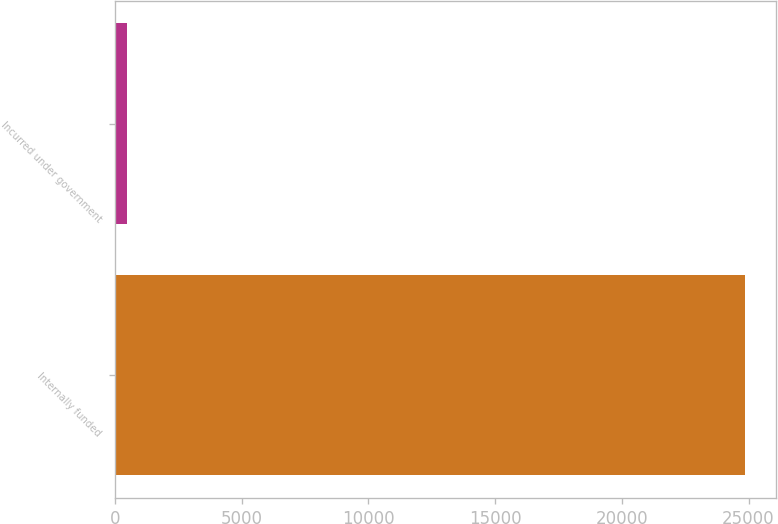<chart> <loc_0><loc_0><loc_500><loc_500><bar_chart><fcel>Internally funded<fcel>Incurred under government<nl><fcel>24849<fcel>479<nl></chart> 